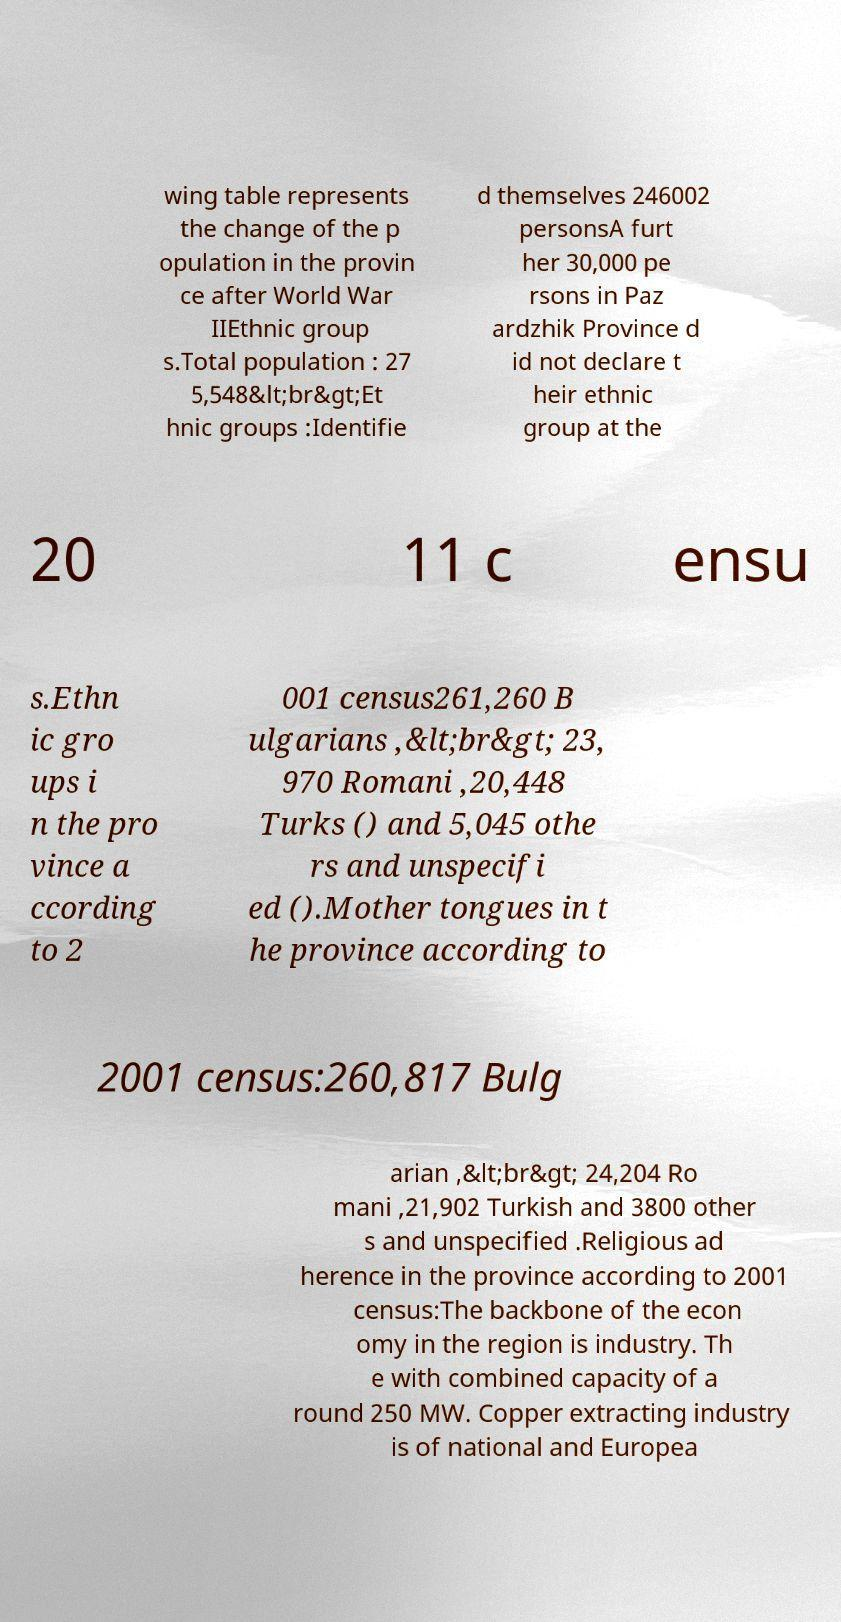Please identify and transcribe the text found in this image. wing table represents the change of the p opulation in the provin ce after World War IIEthnic group s.Total population : 27 5,548&lt;br&gt;Et hnic groups :Identifie d themselves 246002 personsA furt her 30,000 pe rsons in Paz ardzhik Province d id not declare t heir ethnic group at the 20 11 c ensu s.Ethn ic gro ups i n the pro vince a ccording to 2 001 census261,260 B ulgarians ,&lt;br&gt; 23, 970 Romani ,20,448 Turks () and 5,045 othe rs and unspecifi ed ().Mother tongues in t he province according to 2001 census:260,817 Bulg arian ,&lt;br&gt; 24,204 Ro mani ,21,902 Turkish and 3800 other s and unspecified .Religious ad herence in the province according to 2001 census:The backbone of the econ omy in the region is industry. Th e with combined capacity of a round 250 MW. Copper extracting industry is of national and Europea 